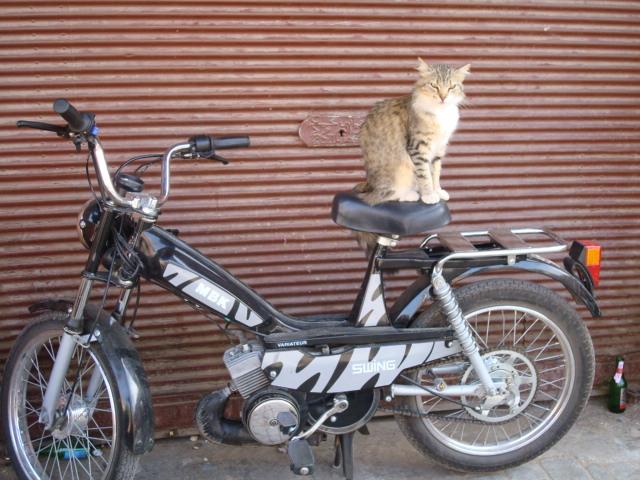What material are the panels on the left and right meant to simulate?
Quick response, please. Metal. What is on the bike?
Concise answer only. Cat. Who manufactured this bike?
Give a very brief answer. Swing. What is sitting on the bike?
Short answer required. Cat. Is the cat running?
Write a very short answer. No. How many tires are there?
Be succinct. 2. Is the cat wearing a helmet?
Concise answer only. No. What is attached to the bicycle?
Answer briefly. Cat. Is there a full bike in the image?
Write a very short answer. Yes. 